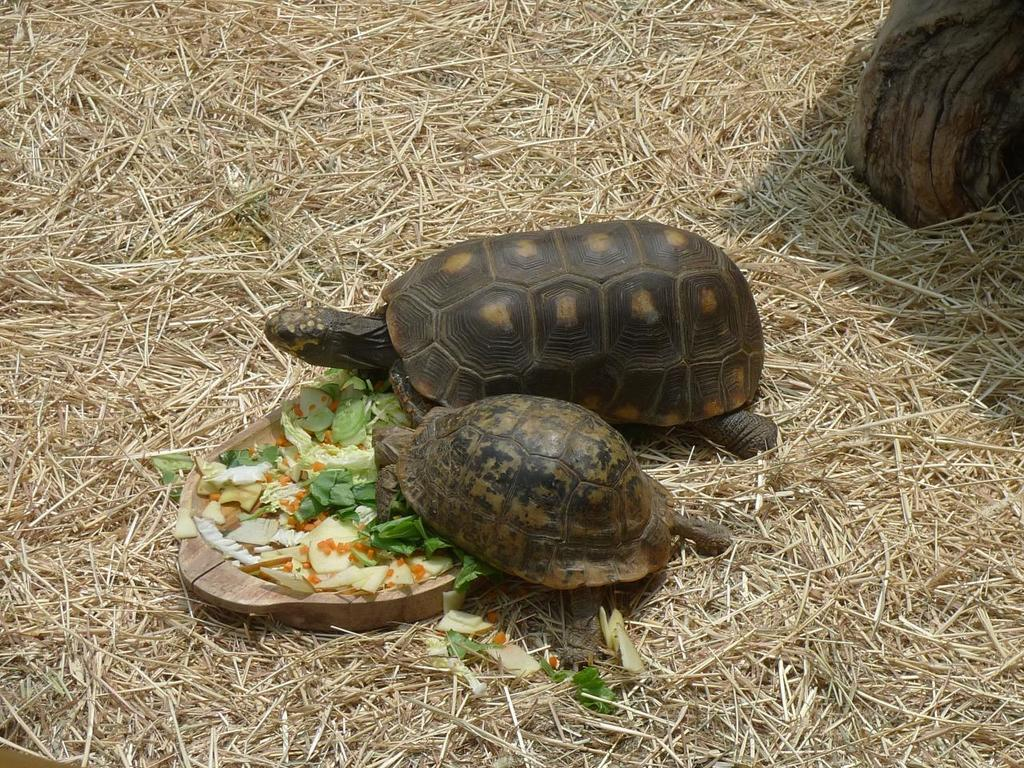What animals can be seen in the image? There are two tortoises in the image. What is the wooden object in the image used for? There is a wooden bowl in the image, which is likely used for holding food. What type of food is in the wooden bowl? There is food in the wooden bowl, but the specific type is not mentioned in the facts. What can be found at the top of the image? There is a wooden object towards the top of the image. What type of vegetation is present in the image? There is dried grass in the image. How many eyes and noses can be seen on the tortoises in the image? Tortoises do not have noses, and the number of eyes cannot be determined from the image alone. 